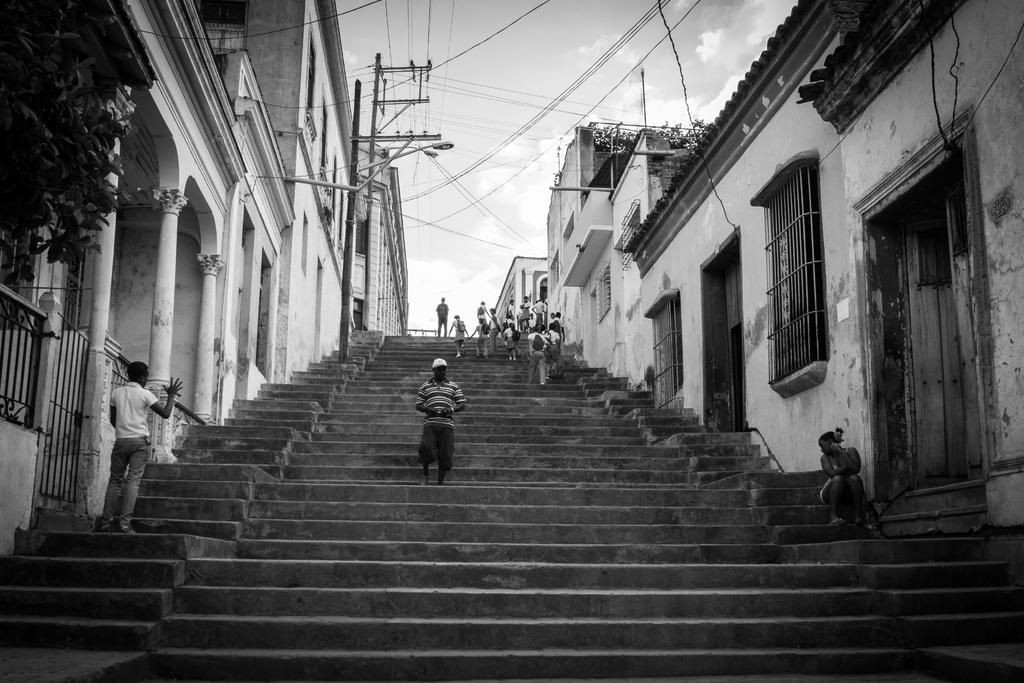What are the people in the image doing? There are persons standing, walking, and sitting in the image. What type of structures can be seen in the image? There are buildings in the image. What other objects are present in the image? There are poles, wires, and plants in the image. How would you describe the weather in the image? The sky is cloudy in the image. Can you see the toes of the people walking in the image? There is no specific detail about the toes of the people walking in the image, so it cannot be determined from the image. Is there a train passing by in the image? There is no train present in the image. 